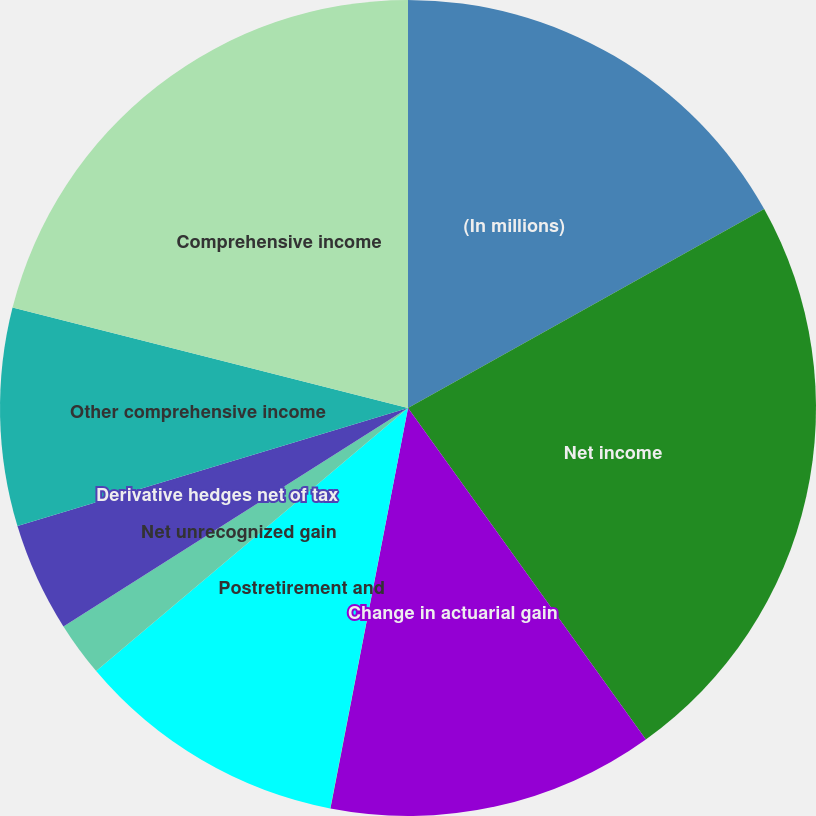Convert chart to OTSL. <chart><loc_0><loc_0><loc_500><loc_500><pie_chart><fcel>(In millions)<fcel>Net income<fcel>Change in actuarial gain<fcel>Income tax benefit (provision)<fcel>Postretirement and<fcel>Net unrecognized gain<fcel>Derivative hedges net of tax<fcel>Other comprehensive income<fcel>Comprehensive income<nl><fcel>16.89%<fcel>23.2%<fcel>12.95%<fcel>0.01%<fcel>10.79%<fcel>2.16%<fcel>4.32%<fcel>8.63%<fcel>21.04%<nl></chart> 